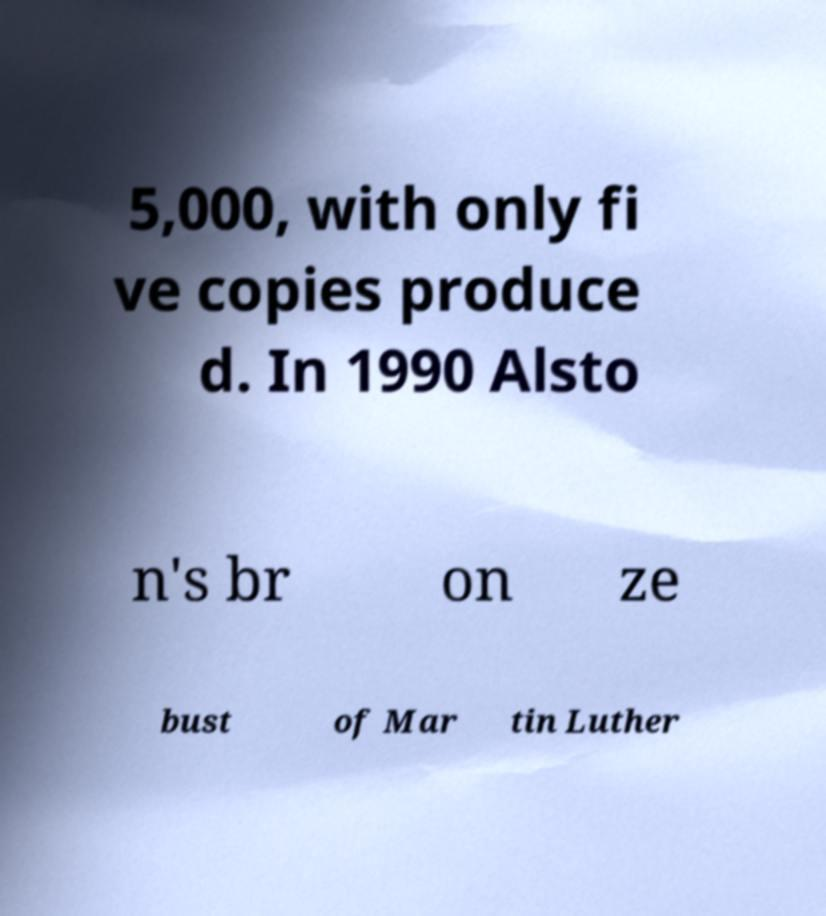I need the written content from this picture converted into text. Can you do that? 5,000, with only fi ve copies produce d. In 1990 Alsto n's br on ze bust of Mar tin Luther 